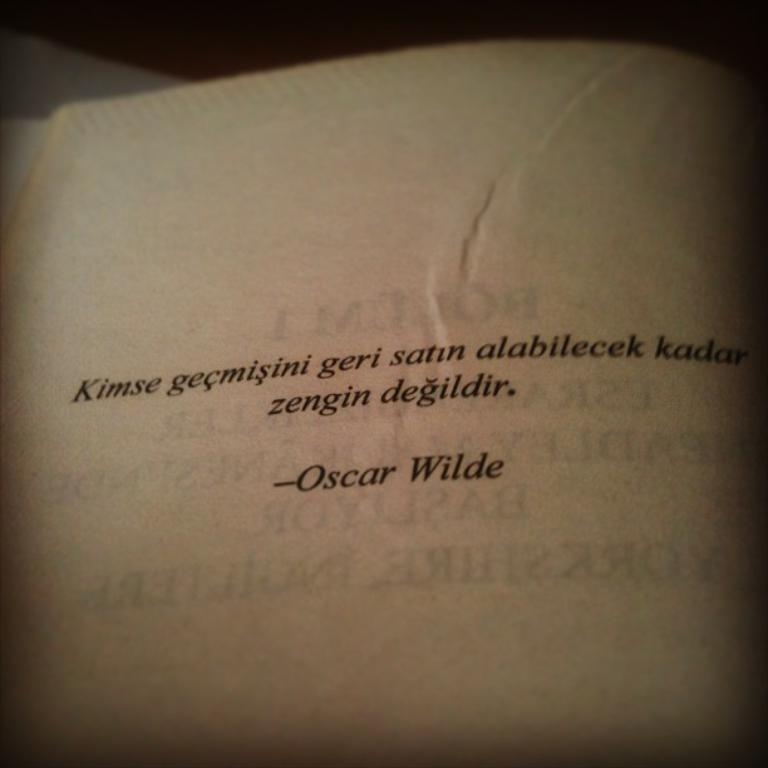<image>
Relay a brief, clear account of the picture shown. Book open on a page that says Oscar Wilde on it. 